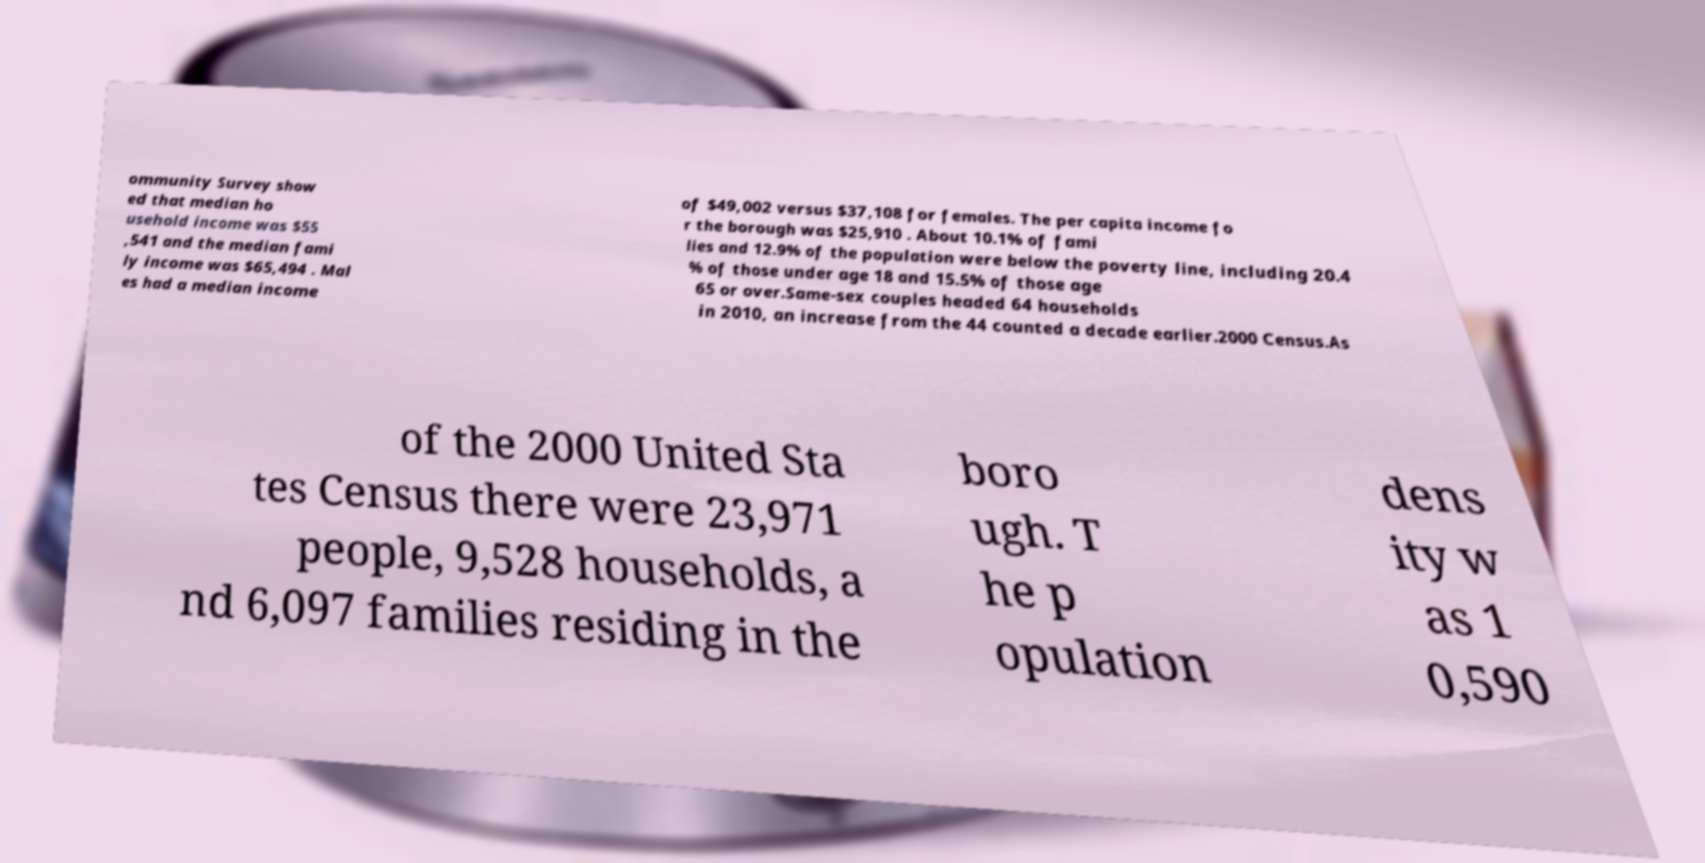Could you assist in decoding the text presented in this image and type it out clearly? ommunity Survey show ed that median ho usehold income was $55 ,541 and the median fami ly income was $65,494 . Mal es had a median income of $49,002 versus $37,108 for females. The per capita income fo r the borough was $25,910 . About 10.1% of fami lies and 12.9% of the population were below the poverty line, including 20.4 % of those under age 18 and 15.5% of those age 65 or over.Same-sex couples headed 64 households in 2010, an increase from the 44 counted a decade earlier.2000 Census.As of the 2000 United Sta tes Census there were 23,971 people, 9,528 households, a nd 6,097 families residing in the boro ugh. T he p opulation dens ity w as 1 0,590 